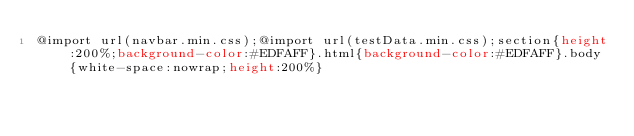<code> <loc_0><loc_0><loc_500><loc_500><_CSS_>@import url(navbar.min.css);@import url(testData.min.css);section{height:200%;background-color:#EDFAFF}.html{background-color:#EDFAFF}.body{white-space:nowrap;height:200%}</code> 